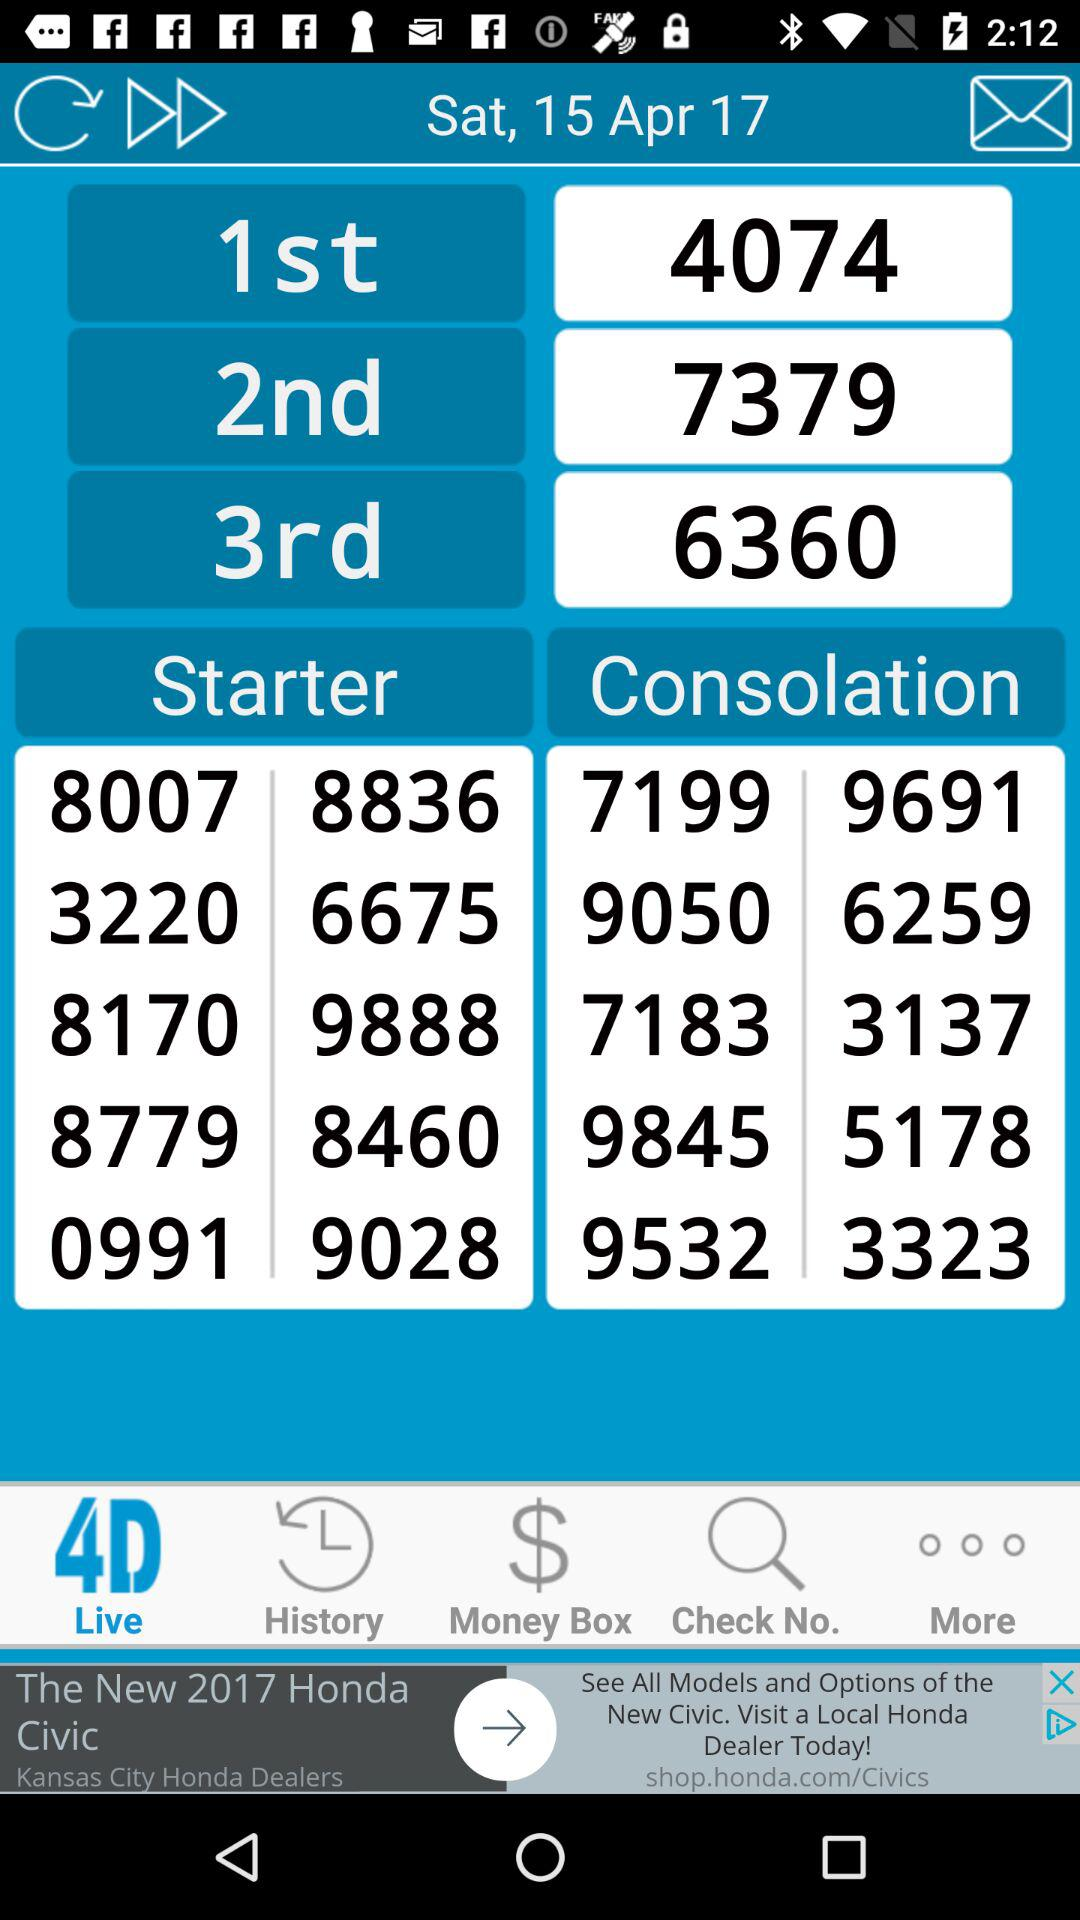What is the date? The date is Saturday, April 15, 2017. 